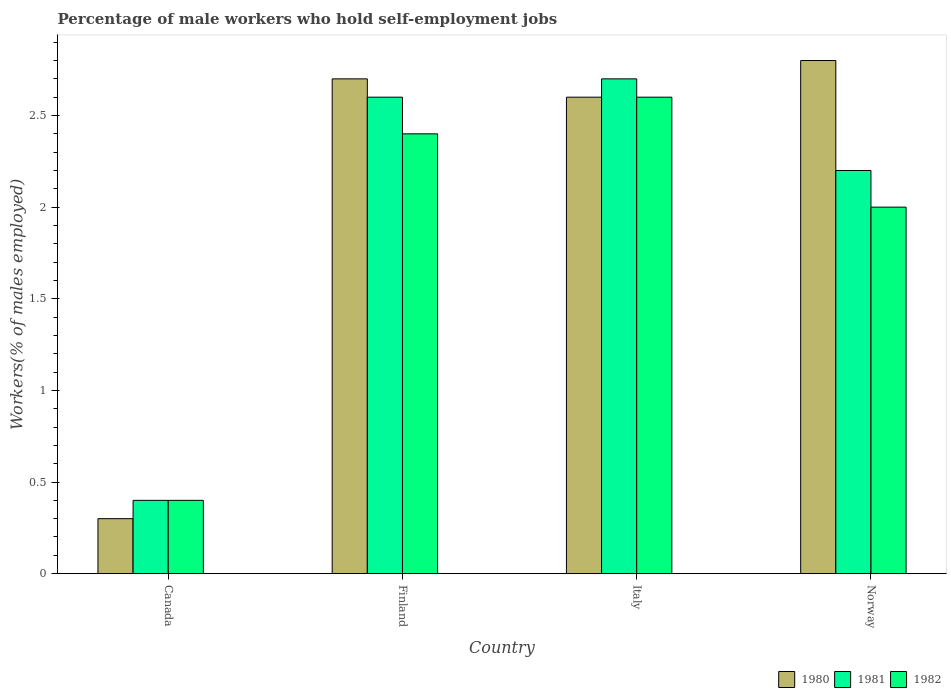How many different coloured bars are there?
Offer a very short reply. 3. How many groups of bars are there?
Your answer should be compact. 4. Are the number of bars on each tick of the X-axis equal?
Give a very brief answer. Yes. How many bars are there on the 4th tick from the right?
Your answer should be compact. 3. What is the percentage of self-employed male workers in 1982 in Canada?
Make the answer very short. 0.4. Across all countries, what is the maximum percentage of self-employed male workers in 1981?
Provide a succinct answer. 2.7. Across all countries, what is the minimum percentage of self-employed male workers in 1982?
Your answer should be compact. 0.4. What is the total percentage of self-employed male workers in 1981 in the graph?
Offer a very short reply. 7.9. What is the difference between the percentage of self-employed male workers in 1981 in Finland and that in Norway?
Your response must be concise. 0.4. What is the difference between the percentage of self-employed male workers in 1980 in Canada and the percentage of self-employed male workers in 1981 in Italy?
Offer a terse response. -2.4. What is the average percentage of self-employed male workers in 1982 per country?
Your answer should be compact. 1.85. What is the difference between the percentage of self-employed male workers of/in 1981 and percentage of self-employed male workers of/in 1980 in Canada?
Your answer should be very brief. 0.1. In how many countries, is the percentage of self-employed male workers in 1982 greater than 2.2 %?
Give a very brief answer. 2. What is the ratio of the percentage of self-employed male workers in 1981 in Canada to that in Norway?
Offer a terse response. 0.18. What is the difference between the highest and the second highest percentage of self-employed male workers in 1982?
Make the answer very short. -0.6. What is the difference between the highest and the lowest percentage of self-employed male workers in 1980?
Give a very brief answer. 2.5. What does the 3rd bar from the left in Norway represents?
Provide a succinct answer. 1982. What does the 1st bar from the right in Norway represents?
Keep it short and to the point. 1982. How many bars are there?
Your response must be concise. 12. Where does the legend appear in the graph?
Give a very brief answer. Bottom right. What is the title of the graph?
Provide a short and direct response. Percentage of male workers who hold self-employment jobs. What is the label or title of the Y-axis?
Provide a succinct answer. Workers(% of males employed). What is the Workers(% of males employed) of 1980 in Canada?
Your response must be concise. 0.3. What is the Workers(% of males employed) of 1981 in Canada?
Offer a very short reply. 0.4. What is the Workers(% of males employed) of 1982 in Canada?
Offer a very short reply. 0.4. What is the Workers(% of males employed) in 1980 in Finland?
Your answer should be compact. 2.7. What is the Workers(% of males employed) of 1981 in Finland?
Keep it short and to the point. 2.6. What is the Workers(% of males employed) of 1982 in Finland?
Keep it short and to the point. 2.4. What is the Workers(% of males employed) in 1980 in Italy?
Provide a short and direct response. 2.6. What is the Workers(% of males employed) in 1981 in Italy?
Give a very brief answer. 2.7. What is the Workers(% of males employed) in 1982 in Italy?
Make the answer very short. 2.6. What is the Workers(% of males employed) in 1980 in Norway?
Make the answer very short. 2.8. What is the Workers(% of males employed) of 1981 in Norway?
Your response must be concise. 2.2. What is the Workers(% of males employed) in 1982 in Norway?
Give a very brief answer. 2. Across all countries, what is the maximum Workers(% of males employed) in 1980?
Ensure brevity in your answer.  2.8. Across all countries, what is the maximum Workers(% of males employed) of 1981?
Your answer should be very brief. 2.7. Across all countries, what is the maximum Workers(% of males employed) of 1982?
Keep it short and to the point. 2.6. Across all countries, what is the minimum Workers(% of males employed) of 1980?
Offer a terse response. 0.3. Across all countries, what is the minimum Workers(% of males employed) in 1981?
Offer a terse response. 0.4. Across all countries, what is the minimum Workers(% of males employed) in 1982?
Provide a succinct answer. 0.4. What is the total Workers(% of males employed) in 1981 in the graph?
Offer a very short reply. 7.9. What is the total Workers(% of males employed) in 1982 in the graph?
Your response must be concise. 7.4. What is the difference between the Workers(% of males employed) of 1981 in Canada and that in Finland?
Offer a very short reply. -2.2. What is the difference between the Workers(% of males employed) of 1982 in Canada and that in Finland?
Your response must be concise. -2. What is the difference between the Workers(% of males employed) in 1980 in Canada and that in Italy?
Offer a very short reply. -2.3. What is the difference between the Workers(% of males employed) of 1982 in Canada and that in Italy?
Offer a very short reply. -2.2. What is the difference between the Workers(% of males employed) of 1980 in Canada and that in Norway?
Give a very brief answer. -2.5. What is the difference between the Workers(% of males employed) in 1981 in Canada and that in Norway?
Offer a very short reply. -1.8. What is the difference between the Workers(% of males employed) in 1980 in Finland and that in Italy?
Give a very brief answer. 0.1. What is the difference between the Workers(% of males employed) in 1982 in Finland and that in Norway?
Provide a succinct answer. 0.4. What is the difference between the Workers(% of males employed) in 1980 in Italy and that in Norway?
Offer a very short reply. -0.2. What is the difference between the Workers(% of males employed) in 1980 in Canada and the Workers(% of males employed) in 1982 in Finland?
Make the answer very short. -2.1. What is the difference between the Workers(% of males employed) of 1981 in Canada and the Workers(% of males employed) of 1982 in Finland?
Give a very brief answer. -2. What is the difference between the Workers(% of males employed) of 1980 in Canada and the Workers(% of males employed) of 1981 in Italy?
Give a very brief answer. -2.4. What is the difference between the Workers(% of males employed) of 1981 in Canada and the Workers(% of males employed) of 1982 in Italy?
Offer a very short reply. -2.2. What is the difference between the Workers(% of males employed) of 1980 in Canada and the Workers(% of males employed) of 1982 in Norway?
Provide a succinct answer. -1.7. What is the difference between the Workers(% of males employed) in 1981 in Canada and the Workers(% of males employed) in 1982 in Norway?
Keep it short and to the point. -1.6. What is the difference between the Workers(% of males employed) in 1980 in Finland and the Workers(% of males employed) in 1982 in Italy?
Keep it short and to the point. 0.1. What is the difference between the Workers(% of males employed) of 1980 in Finland and the Workers(% of males employed) of 1981 in Norway?
Make the answer very short. 0.5. What is the difference between the Workers(% of males employed) of 1981 in Finland and the Workers(% of males employed) of 1982 in Norway?
Your answer should be very brief. 0.6. What is the difference between the Workers(% of males employed) in 1980 in Italy and the Workers(% of males employed) in 1981 in Norway?
Keep it short and to the point. 0.4. What is the average Workers(% of males employed) of 1981 per country?
Give a very brief answer. 1.98. What is the average Workers(% of males employed) of 1982 per country?
Give a very brief answer. 1.85. What is the difference between the Workers(% of males employed) of 1980 and Workers(% of males employed) of 1982 in Canada?
Make the answer very short. -0.1. What is the difference between the Workers(% of males employed) in 1981 and Workers(% of males employed) in 1982 in Finland?
Provide a succinct answer. 0.2. What is the difference between the Workers(% of males employed) in 1980 and Workers(% of males employed) in 1981 in Italy?
Your response must be concise. -0.1. What is the difference between the Workers(% of males employed) of 1980 and Workers(% of males employed) of 1982 in Italy?
Offer a terse response. 0. What is the difference between the Workers(% of males employed) of 1981 and Workers(% of males employed) of 1982 in Italy?
Make the answer very short. 0.1. What is the difference between the Workers(% of males employed) of 1980 and Workers(% of males employed) of 1982 in Norway?
Your answer should be very brief. 0.8. What is the ratio of the Workers(% of males employed) of 1981 in Canada to that in Finland?
Offer a very short reply. 0.15. What is the ratio of the Workers(% of males employed) in 1980 in Canada to that in Italy?
Your answer should be compact. 0.12. What is the ratio of the Workers(% of males employed) in 1981 in Canada to that in Italy?
Your response must be concise. 0.15. What is the ratio of the Workers(% of males employed) of 1982 in Canada to that in Italy?
Keep it short and to the point. 0.15. What is the ratio of the Workers(% of males employed) of 1980 in Canada to that in Norway?
Keep it short and to the point. 0.11. What is the ratio of the Workers(% of males employed) of 1981 in Canada to that in Norway?
Provide a succinct answer. 0.18. What is the ratio of the Workers(% of males employed) in 1982 in Finland to that in Italy?
Offer a terse response. 0.92. What is the ratio of the Workers(% of males employed) of 1980 in Finland to that in Norway?
Offer a very short reply. 0.96. What is the ratio of the Workers(% of males employed) of 1981 in Finland to that in Norway?
Your answer should be compact. 1.18. What is the ratio of the Workers(% of males employed) in 1980 in Italy to that in Norway?
Offer a terse response. 0.93. What is the ratio of the Workers(% of males employed) in 1981 in Italy to that in Norway?
Give a very brief answer. 1.23. What is the difference between the highest and the second highest Workers(% of males employed) of 1980?
Ensure brevity in your answer.  0.1. What is the difference between the highest and the second highest Workers(% of males employed) of 1981?
Provide a succinct answer. 0.1. What is the difference between the highest and the second highest Workers(% of males employed) of 1982?
Make the answer very short. 0.2. What is the difference between the highest and the lowest Workers(% of males employed) of 1980?
Make the answer very short. 2.5. 